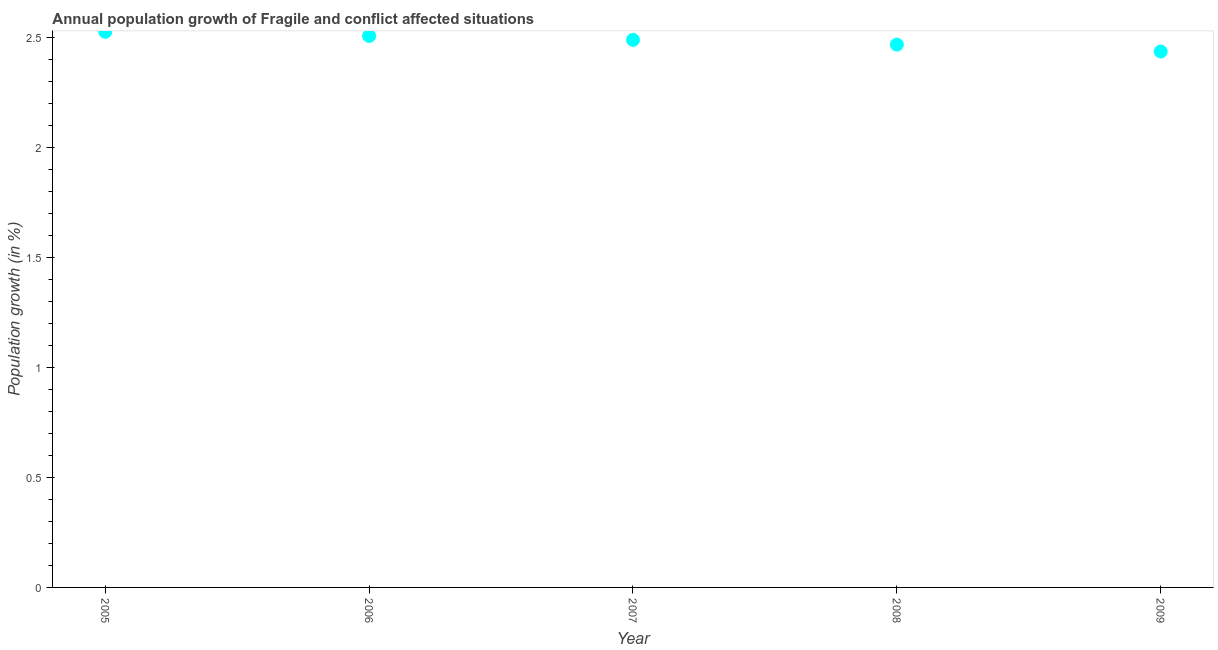What is the population growth in 2009?
Provide a short and direct response. 2.44. Across all years, what is the maximum population growth?
Make the answer very short. 2.53. Across all years, what is the minimum population growth?
Your answer should be very brief. 2.44. In which year was the population growth minimum?
Give a very brief answer. 2009. What is the sum of the population growth?
Offer a very short reply. 12.43. What is the difference between the population growth in 2007 and 2008?
Your answer should be compact. 0.02. What is the average population growth per year?
Your answer should be very brief. 2.49. What is the median population growth?
Offer a terse response. 2.49. What is the ratio of the population growth in 2007 to that in 2008?
Your answer should be compact. 1.01. Is the population growth in 2006 less than that in 2007?
Provide a succinct answer. No. What is the difference between the highest and the second highest population growth?
Keep it short and to the point. 0.02. Is the sum of the population growth in 2006 and 2008 greater than the maximum population growth across all years?
Provide a short and direct response. Yes. What is the difference between the highest and the lowest population growth?
Ensure brevity in your answer.  0.09. In how many years, is the population growth greater than the average population growth taken over all years?
Make the answer very short. 3. How many dotlines are there?
Offer a very short reply. 1. How many years are there in the graph?
Give a very brief answer. 5. What is the difference between two consecutive major ticks on the Y-axis?
Offer a very short reply. 0.5. Does the graph contain any zero values?
Your answer should be very brief. No. Does the graph contain grids?
Offer a very short reply. No. What is the title of the graph?
Offer a terse response. Annual population growth of Fragile and conflict affected situations. What is the label or title of the Y-axis?
Ensure brevity in your answer.  Population growth (in %). What is the Population growth (in %) in 2005?
Keep it short and to the point. 2.53. What is the Population growth (in %) in 2006?
Keep it short and to the point. 2.51. What is the Population growth (in %) in 2007?
Offer a very short reply. 2.49. What is the Population growth (in %) in 2008?
Ensure brevity in your answer.  2.47. What is the Population growth (in %) in 2009?
Your answer should be very brief. 2.44. What is the difference between the Population growth (in %) in 2005 and 2006?
Offer a terse response. 0.02. What is the difference between the Population growth (in %) in 2005 and 2007?
Keep it short and to the point. 0.04. What is the difference between the Population growth (in %) in 2005 and 2008?
Provide a short and direct response. 0.06. What is the difference between the Population growth (in %) in 2005 and 2009?
Keep it short and to the point. 0.09. What is the difference between the Population growth (in %) in 2006 and 2007?
Keep it short and to the point. 0.02. What is the difference between the Population growth (in %) in 2006 and 2008?
Your answer should be very brief. 0.04. What is the difference between the Population growth (in %) in 2006 and 2009?
Provide a short and direct response. 0.07. What is the difference between the Population growth (in %) in 2007 and 2008?
Your response must be concise. 0.02. What is the difference between the Population growth (in %) in 2007 and 2009?
Offer a very short reply. 0.05. What is the difference between the Population growth (in %) in 2008 and 2009?
Your answer should be very brief. 0.03. What is the ratio of the Population growth (in %) in 2005 to that in 2007?
Offer a very short reply. 1.01. What is the ratio of the Population growth (in %) in 2006 to that in 2007?
Provide a short and direct response. 1.01. What is the ratio of the Population growth (in %) in 2006 to that in 2009?
Offer a very short reply. 1.03. 